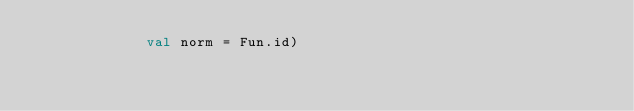Convert code to text. <code><loc_0><loc_0><loc_500><loc_500><_SML_>             val norm = Fun.id)

</code> 